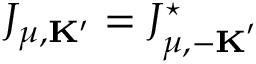<formula> <loc_0><loc_0><loc_500><loc_500>J _ { \mu , { K } ^ { \prime } } = J _ { \mu , { - K } ^ { \prime } } ^ { ^ { * } }</formula> 